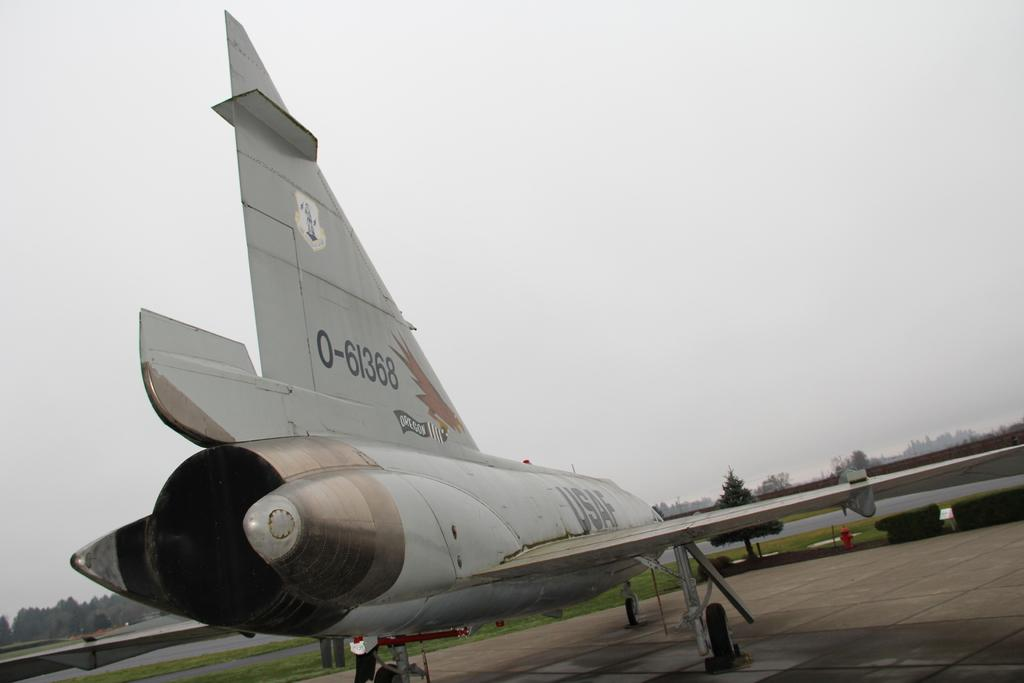<image>
Describe the image concisely. An airplane with a bird holding a banner that says Oregon 